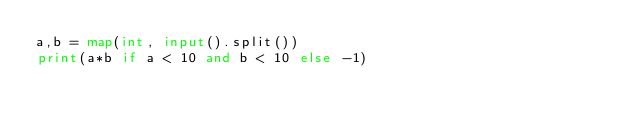Convert code to text. <code><loc_0><loc_0><loc_500><loc_500><_Python_>a,b = map(int, input().split())
print(a*b if a < 10 and b < 10 else -1)</code> 